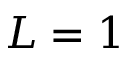<formula> <loc_0><loc_0><loc_500><loc_500>L = 1</formula> 